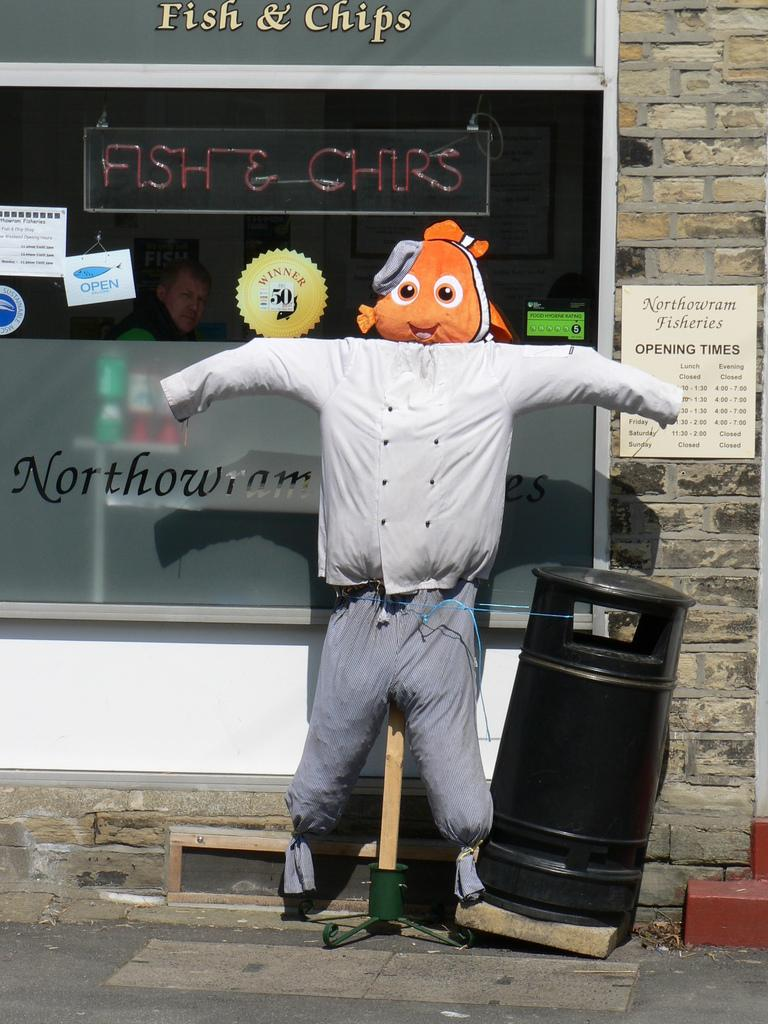<image>
Relay a brief, clear account of the picture shown. A mannequin with a fish head standing outside a store window with the word chips on it. 